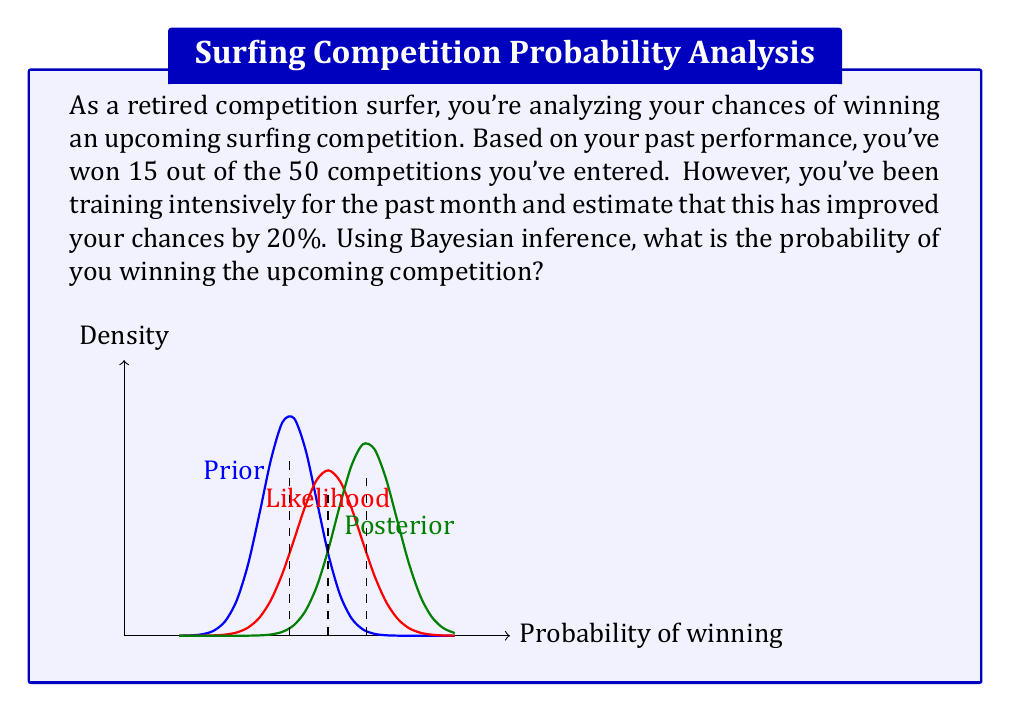Help me with this question. Let's approach this step-by-step using Bayesian inference:

1) First, we need to establish our prior probability. Based on past performance:

   $P(\text{win}) = \frac{15}{50} = 0.3$

2) Now, we need to incorporate the new information about your intensive training. This will form our likelihood. The training is estimated to improve your chances by 20%:

   $P(\text{training}|\text{win}) = 0.3 * 1.2 = 0.36$

3) To apply Bayes' theorem, we need to calculate $P(\text{training})$:

   $P(\text{training}) = P(\text{training}|\text{win})P(\text{win}) + P(\text{training}|\text{not win})P(\text{not win})$
   $= 0.36 * 0.3 + 0.3 * 0.7 = 0.108 + 0.21 = 0.318$

4) Now we can apply Bayes' theorem:

   $P(\text{win}|\text{training}) = \frac{P(\text{training}|\text{win})P(\text{win})}{P(\text{training})}$

   $= \frac{0.36 * 0.3}{0.318} \approx 0.3396$

5) Converting to a percentage:

   $0.3396 * 100 \approx 33.96\%$

Therefore, given your past performance and recent intensive training, the probability of winning the upcoming competition is approximately 33.96%.
Answer: $33.96\%$ 